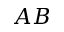Convert formula to latex. <formula><loc_0><loc_0><loc_500><loc_500>A B</formula> 